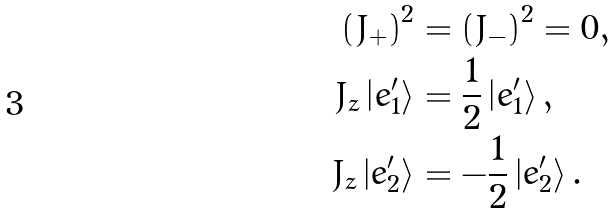<formula> <loc_0><loc_0><loc_500><loc_500>\left ( J _ { + } \right ) ^ { 2 } & = \left ( J _ { - } \right ) ^ { 2 } = 0 , \\ J _ { z } \left | e _ { 1 } ^ { \prime } \right \rangle & = \frac { 1 } { 2 } \left | e _ { 1 } ^ { \prime } \right \rangle , \\ J _ { z } \left | e _ { 2 } ^ { \prime } \right \rangle & = - \frac { 1 } { 2 } \left | e _ { 2 } ^ { \prime } \right \rangle .</formula> 